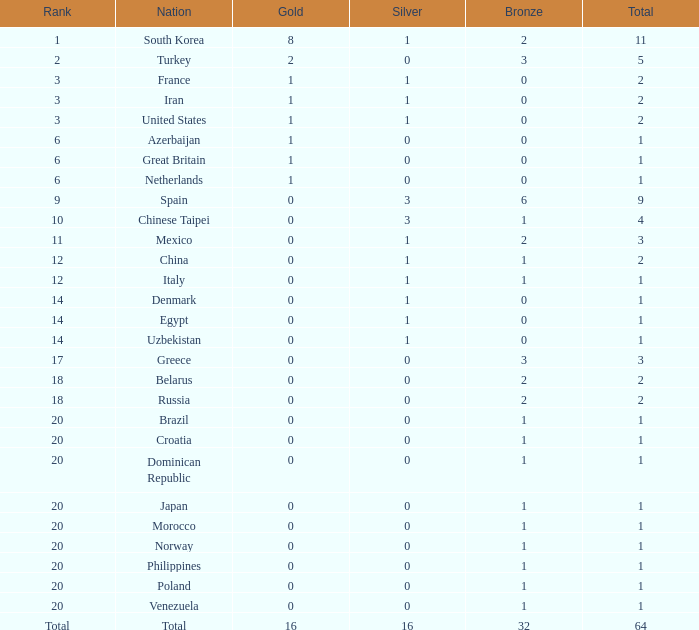What is the average number of bronze of the nation with more than 1 gold and 1 silver medal? 2.0. Can you parse all the data within this table? {'header': ['Rank', 'Nation', 'Gold', 'Silver', 'Bronze', 'Total'], 'rows': [['1', 'South Korea', '8', '1', '2', '11'], ['2', 'Turkey', '2', '0', '3', '5'], ['3', 'France', '1', '1', '0', '2'], ['3', 'Iran', '1', '1', '0', '2'], ['3', 'United States', '1', '1', '0', '2'], ['6', 'Azerbaijan', '1', '0', '0', '1'], ['6', 'Great Britain', '1', '0', '0', '1'], ['6', 'Netherlands', '1', '0', '0', '1'], ['9', 'Spain', '0', '3', '6', '9'], ['10', 'Chinese Taipei', '0', '3', '1', '4'], ['11', 'Mexico', '0', '1', '2', '3'], ['12', 'China', '0', '1', '1', '2'], ['12', 'Italy', '0', '1', '1', '1'], ['14', 'Denmark', '0', '1', '0', '1'], ['14', 'Egypt', '0', '1', '0', '1'], ['14', 'Uzbekistan', '0', '1', '0', '1'], ['17', 'Greece', '0', '0', '3', '3'], ['18', 'Belarus', '0', '0', '2', '2'], ['18', 'Russia', '0', '0', '2', '2'], ['20', 'Brazil', '0', '0', '1', '1'], ['20', 'Croatia', '0', '0', '1', '1'], ['20', 'Dominican Republic', '0', '0', '1', '1'], ['20', 'Japan', '0', '0', '1', '1'], ['20', 'Morocco', '0', '0', '1', '1'], ['20', 'Norway', '0', '0', '1', '1'], ['20', 'Philippines', '0', '0', '1', '1'], ['20', 'Poland', '0', '0', '1', '1'], ['20', 'Venezuela', '0', '0', '1', '1'], ['Total', 'Total', '16', '16', '32', '64']]} 